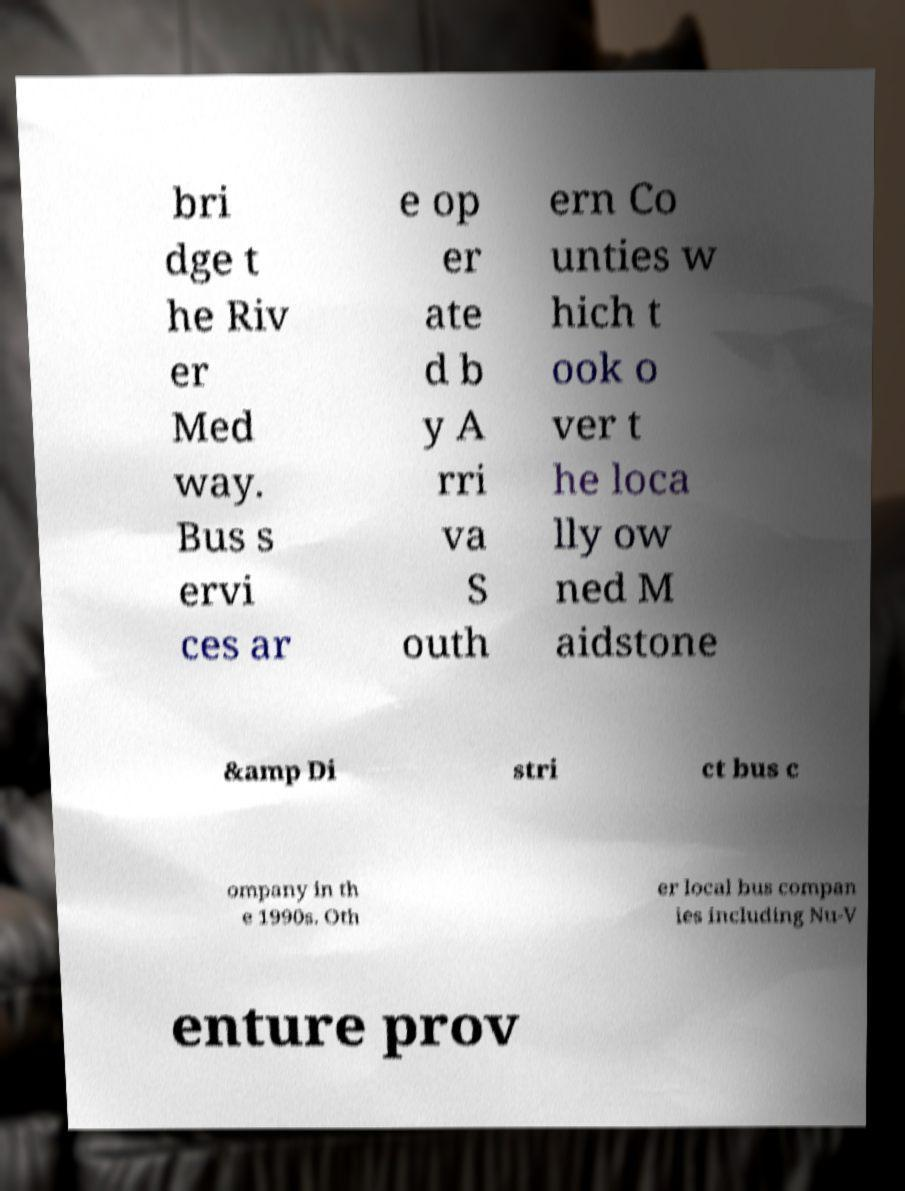For documentation purposes, I need the text within this image transcribed. Could you provide that? bri dge t he Riv er Med way. Bus s ervi ces ar e op er ate d b y A rri va S outh ern Co unties w hich t ook o ver t he loca lly ow ned M aidstone &amp Di stri ct bus c ompany in th e 1990s. Oth er local bus compan ies including Nu-V enture prov 